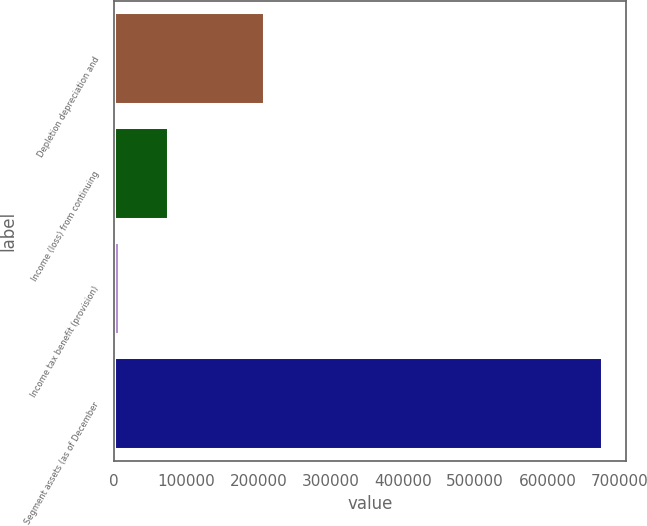Convert chart. <chart><loc_0><loc_0><loc_500><loc_500><bar_chart><fcel>Depletion depreciation and<fcel>Income (loss) from continuing<fcel>Income tax benefit (provision)<fcel>Segment assets (as of December<nl><fcel>207677<fcel>74035.1<fcel>7214<fcel>675425<nl></chart> 